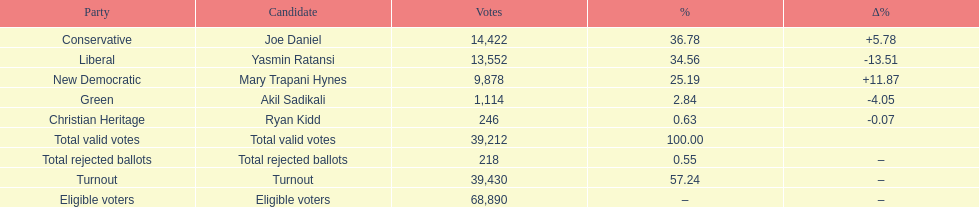Which contender received the highest number of votes? Joe Daniel. Help me parse the entirety of this table. {'header': ['Party', 'Candidate', 'Votes', '%', '∆%'], 'rows': [['Conservative', 'Joe Daniel', '14,422', '36.78', '+5.78'], ['Liberal', 'Yasmin Ratansi', '13,552', '34.56', '-13.51'], ['New Democratic', 'Mary Trapani Hynes', '9,878', '25.19', '+11.87'], ['Green', 'Akil Sadikali', '1,114', '2.84', '-4.05'], ['Christian Heritage', 'Ryan Kidd', '246', '0.63', '-0.07'], ['Total valid votes', 'Total valid votes', '39,212', '100.00', ''], ['Total rejected ballots', 'Total rejected ballots', '218', '0.55', '–'], ['Turnout', 'Turnout', '39,430', '57.24', '–'], ['Eligible voters', 'Eligible voters', '68,890', '–', '–']]} 